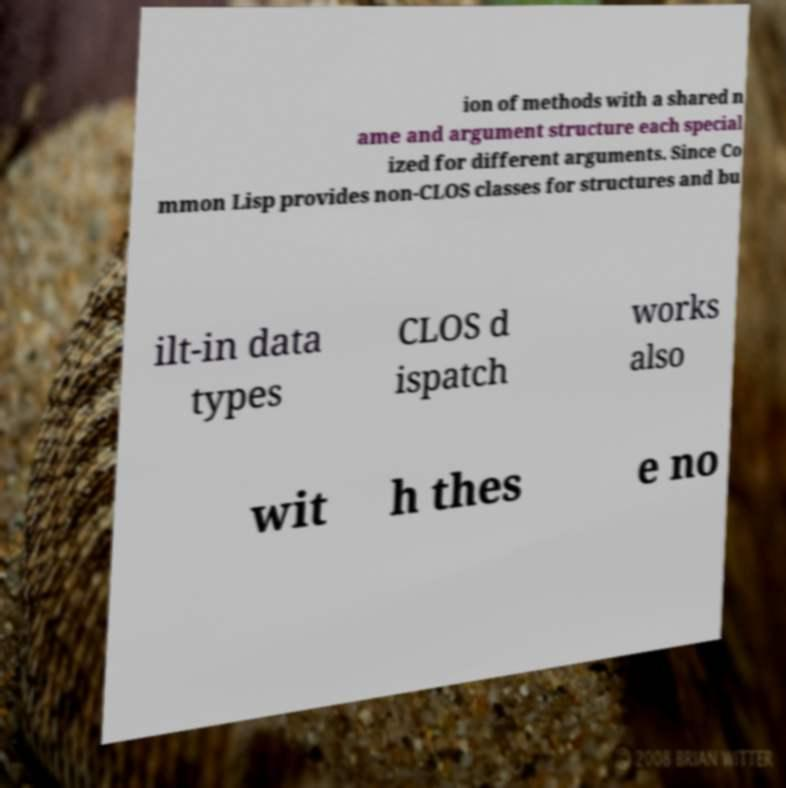Can you accurately transcribe the text from the provided image for me? ion of methods with a shared n ame and argument structure each special ized for different arguments. Since Co mmon Lisp provides non-CLOS classes for structures and bu ilt-in data types CLOS d ispatch works also wit h thes e no 